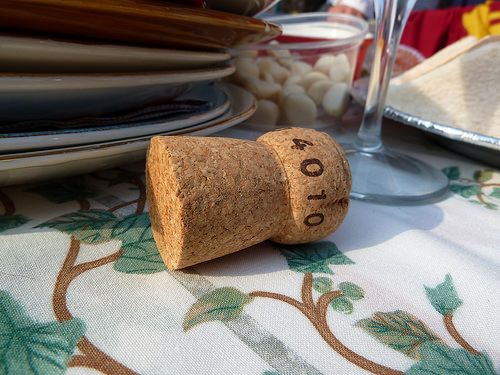<image>
Can you confirm if the cork is next to the leaf? Yes. The cork is positioned adjacent to the leaf, located nearby in the same general area. 